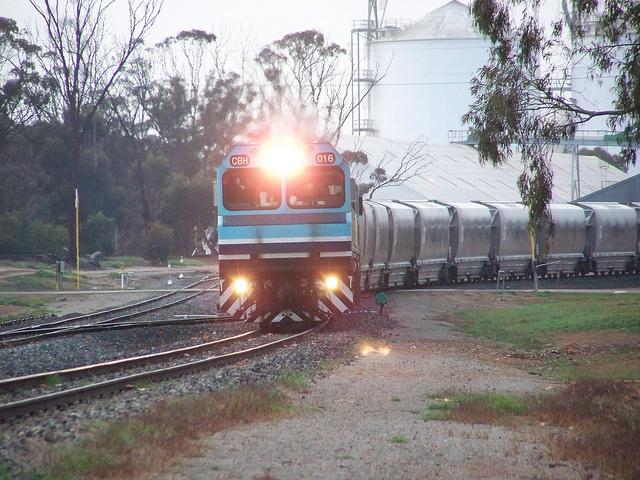How many lights are there?
Keep it brief. 3. Is the light bright?
Write a very short answer. Yes. Is there anyone on the train track?
Give a very brief answer. No. 